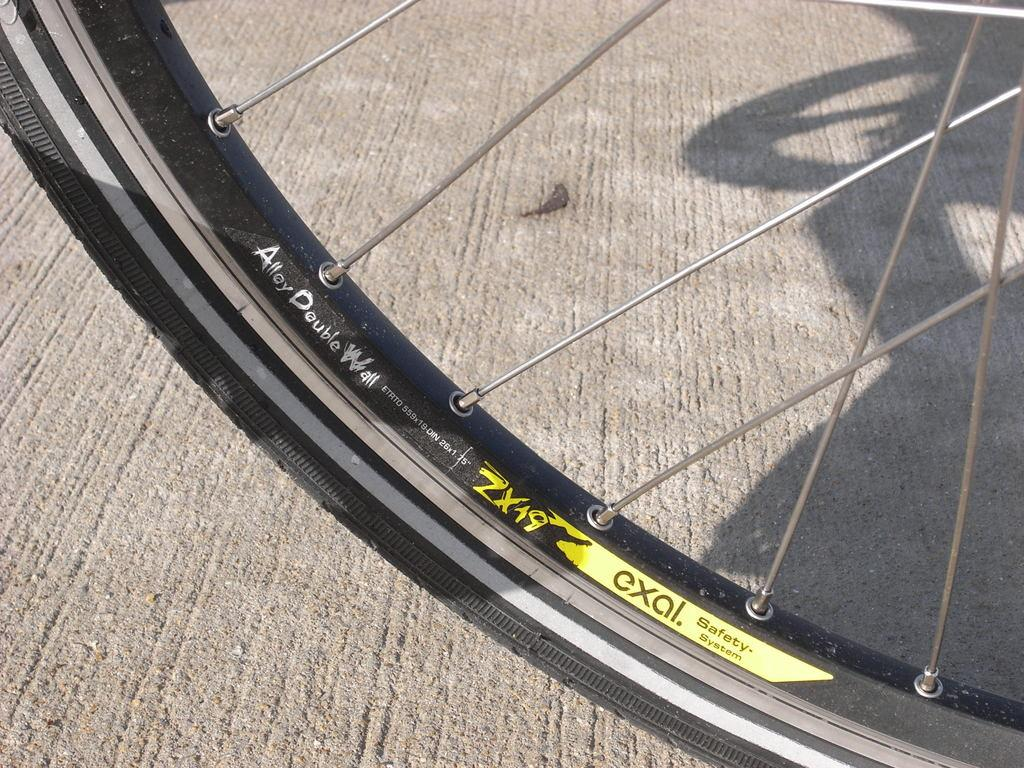What object is featured in the image? There is a wheel of a bicycle in the image. What can be observed about the structure of the wheel? The wheel has spokes. How does the thumb contribute to the functionality of the bicycle wheel in the image? There is no thumb present in the image, and it does not contribute to the functionality of the bicycle wheel. 